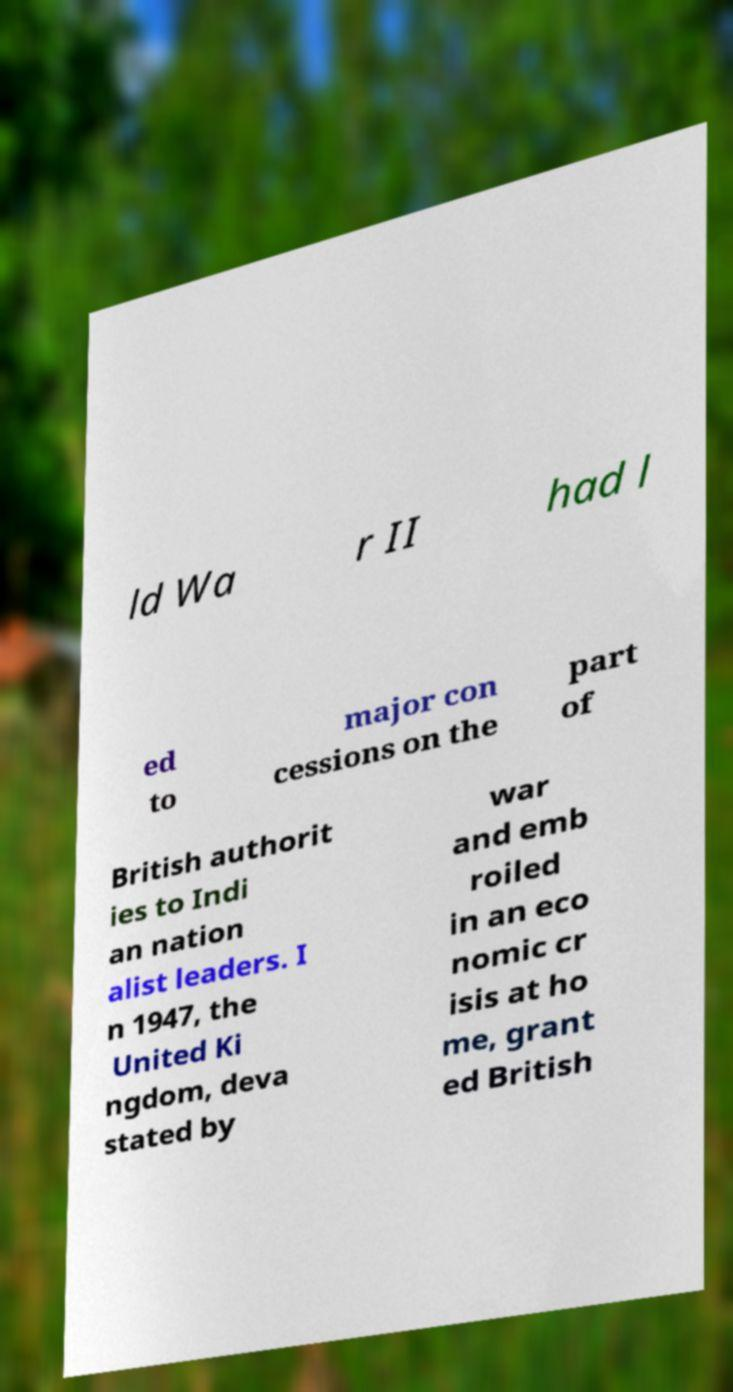I need the written content from this picture converted into text. Can you do that? ld Wa r II had l ed to major con cessions on the part of British authorit ies to Indi an nation alist leaders. I n 1947, the United Ki ngdom, deva stated by war and emb roiled in an eco nomic cr isis at ho me, grant ed British 